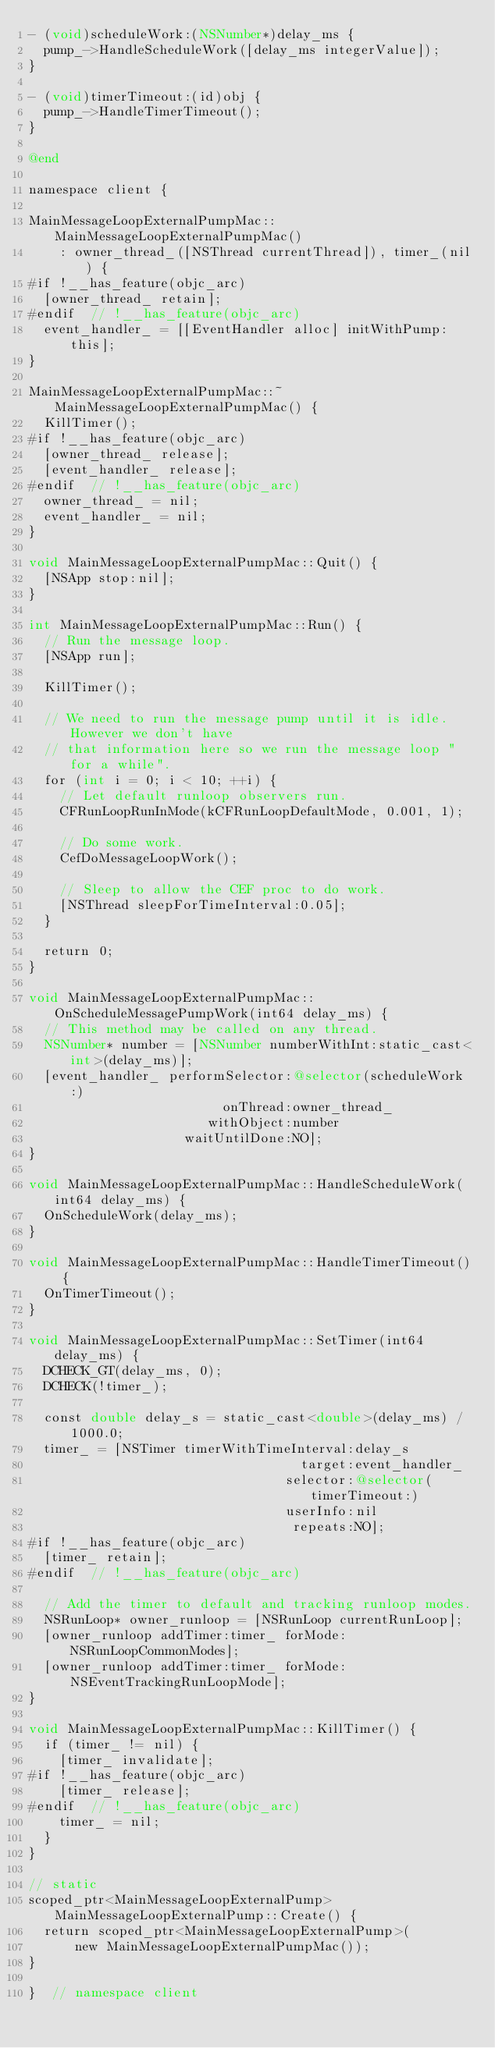<code> <loc_0><loc_0><loc_500><loc_500><_ObjectiveC_>- (void)scheduleWork:(NSNumber*)delay_ms {
  pump_->HandleScheduleWork([delay_ms integerValue]);
}

- (void)timerTimeout:(id)obj {
  pump_->HandleTimerTimeout();
}

@end

namespace client {

MainMessageLoopExternalPumpMac::MainMessageLoopExternalPumpMac()
    : owner_thread_([NSThread currentThread]), timer_(nil) {
#if !__has_feature(objc_arc)
  [owner_thread_ retain];
#endif  // !__has_feature(objc_arc)
  event_handler_ = [[EventHandler alloc] initWithPump:this];
}

MainMessageLoopExternalPumpMac::~MainMessageLoopExternalPumpMac() {
  KillTimer();
#if !__has_feature(objc_arc)
  [owner_thread_ release];
  [event_handler_ release];
#endif  // !__has_feature(objc_arc)
  owner_thread_ = nil;
  event_handler_ = nil;
}

void MainMessageLoopExternalPumpMac::Quit() {
  [NSApp stop:nil];
}

int MainMessageLoopExternalPumpMac::Run() {
  // Run the message loop.
  [NSApp run];

  KillTimer();

  // We need to run the message pump until it is idle. However we don't have
  // that information here so we run the message loop "for a while".
  for (int i = 0; i < 10; ++i) {
    // Let default runloop observers run.
    CFRunLoopRunInMode(kCFRunLoopDefaultMode, 0.001, 1);

    // Do some work.
    CefDoMessageLoopWork();

    // Sleep to allow the CEF proc to do work.
    [NSThread sleepForTimeInterval:0.05];
  }

  return 0;
}

void MainMessageLoopExternalPumpMac::OnScheduleMessagePumpWork(int64 delay_ms) {
  // This method may be called on any thread.
  NSNumber* number = [NSNumber numberWithInt:static_cast<int>(delay_ms)];
  [event_handler_ performSelector:@selector(scheduleWork:)
                         onThread:owner_thread_
                       withObject:number
                    waitUntilDone:NO];
}

void MainMessageLoopExternalPumpMac::HandleScheduleWork(int64 delay_ms) {
  OnScheduleWork(delay_ms);
}

void MainMessageLoopExternalPumpMac::HandleTimerTimeout() {
  OnTimerTimeout();
}

void MainMessageLoopExternalPumpMac::SetTimer(int64 delay_ms) {
  DCHECK_GT(delay_ms, 0);
  DCHECK(!timer_);

  const double delay_s = static_cast<double>(delay_ms) / 1000.0;
  timer_ = [NSTimer timerWithTimeInterval:delay_s
                                   target:event_handler_
                                 selector:@selector(timerTimeout:)
                                 userInfo:nil
                                  repeats:NO];
#if !__has_feature(objc_arc)
  [timer_ retain];
#endif  // !__has_feature(objc_arc)

  // Add the timer to default and tracking runloop modes.
  NSRunLoop* owner_runloop = [NSRunLoop currentRunLoop];
  [owner_runloop addTimer:timer_ forMode:NSRunLoopCommonModes];
  [owner_runloop addTimer:timer_ forMode:NSEventTrackingRunLoopMode];
}

void MainMessageLoopExternalPumpMac::KillTimer() {
  if (timer_ != nil) {
    [timer_ invalidate];
#if !__has_feature(objc_arc)
    [timer_ release];
#endif  // !__has_feature(objc_arc)
    timer_ = nil;
  }
}

// static
scoped_ptr<MainMessageLoopExternalPump> MainMessageLoopExternalPump::Create() {
  return scoped_ptr<MainMessageLoopExternalPump>(
      new MainMessageLoopExternalPumpMac());
}

}  // namespace client
</code> 